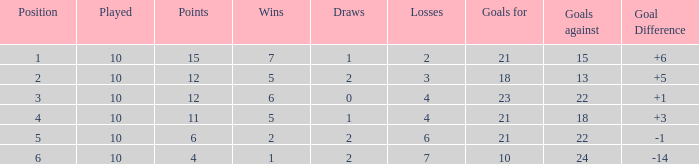Can you provide the minimum games played with a position higher than 2, fewer than 2 draws, and less than 18 goals against? None. 